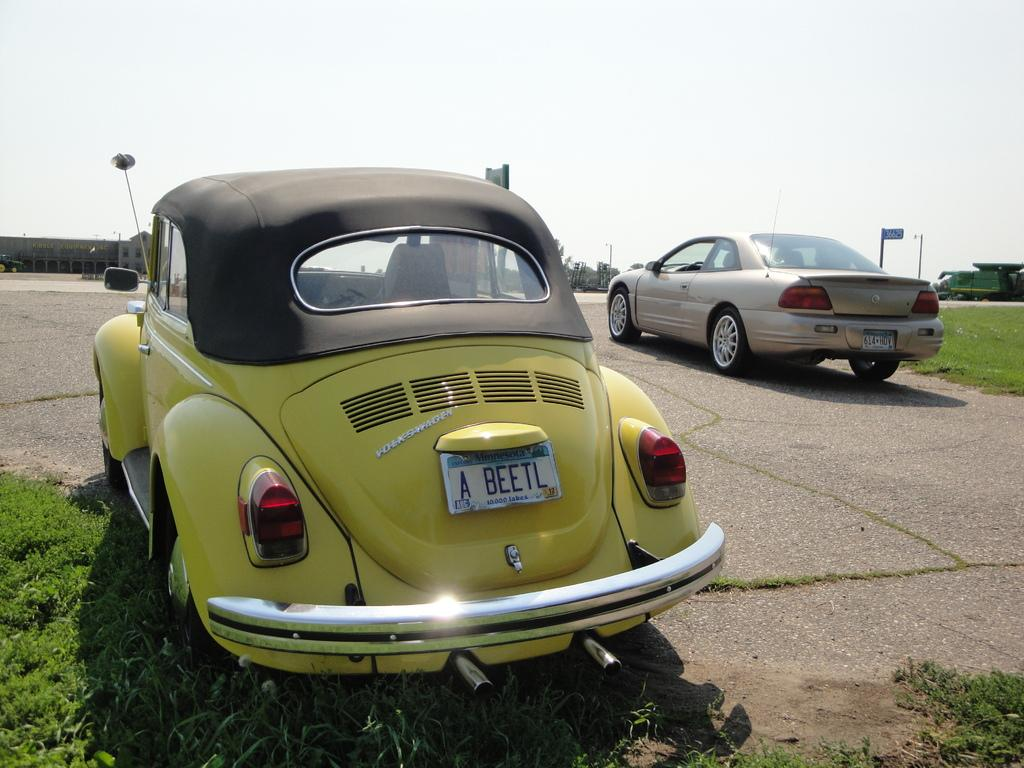What is happening on the road in the image? There are vehicles on the road in the image. What can be seen in the distance behind the vehicles? There are buildings, poles, and trees visible in the background of the image. What is the ground covered with at the bottom of the image? The ground is covered with grass at the bottom of the image. Who is talking to the pocket in the image? There is no pocket or person talking to a pocket present in the image. 